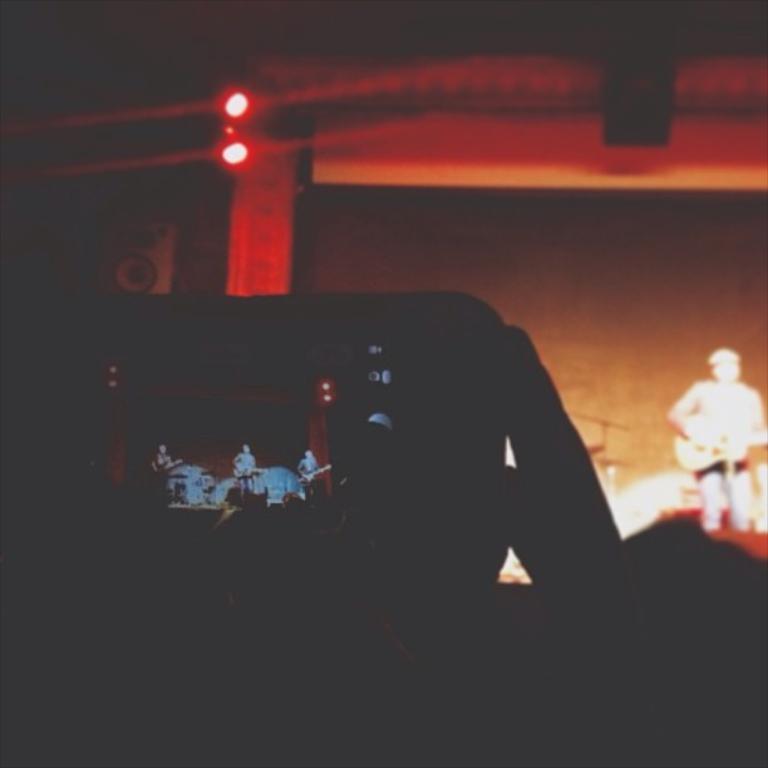Please provide a concise description of this image. At the bottom of the image we can see a person is holding a mobile. On the right side of the image we can see a man is standing and playing a guitar. In the background of the image we can see the wall, pillar, lights. speaker. At the top of the image we can see the roof. 